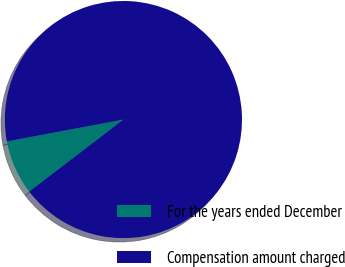Convert chart. <chart><loc_0><loc_0><loc_500><loc_500><pie_chart><fcel>For the years ended December<fcel>Compensation amount charged<nl><fcel>7.44%<fcel>92.56%<nl></chart> 